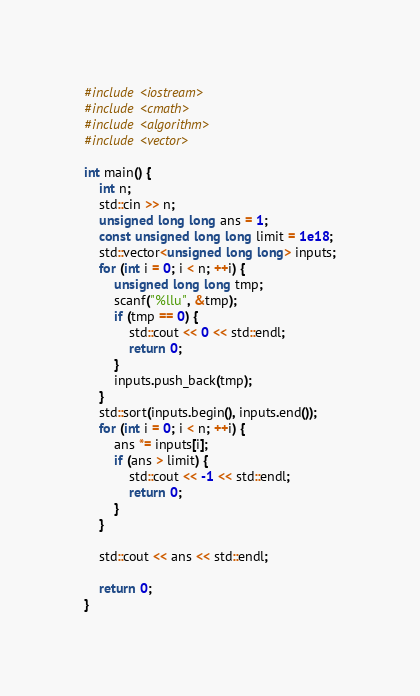Convert code to text. <code><loc_0><loc_0><loc_500><loc_500><_C++_>
#include <iostream>
#include <cmath>
#include <algorithm>
#include <vector>

int main() {
	int n;
	std::cin >> n;
	unsigned long long ans = 1;
	const unsigned long long limit = 1e18;
	std::vector<unsigned long long> inputs;
	for (int i = 0; i < n; ++i) {
		unsigned long long tmp;
		scanf("%llu", &tmp);
		if (tmp == 0) {
			std::cout << 0 << std::endl;
			return 0;
		}
		inputs.push_back(tmp);
	}
	std::sort(inputs.begin(), inputs.end());
	for (int i = 0; i < n; ++i) {
		ans *= inputs[i];
		if (ans > limit) {
			std::cout << -1 << std::endl;
			return 0;
		}
	}

	std::cout << ans << std::endl;

	return 0;
}</code> 